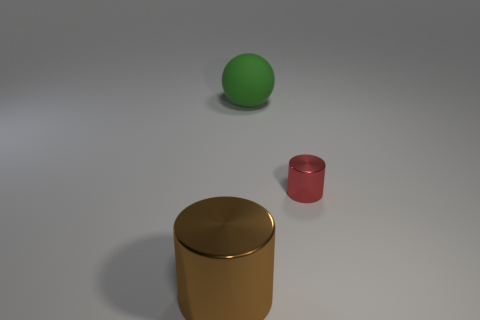Are there any brown things that have the same size as the green sphere?
Offer a terse response. Yes. There is a tiny cylinder that is the same material as the brown thing; what is its color?
Keep it short and to the point. Red. There is a large thing that is behind the large shiny cylinder; what number of balls are in front of it?
Your answer should be compact. 0. What is the thing that is both in front of the big matte thing and to the left of the small object made of?
Make the answer very short. Metal. Do the metal object that is to the left of the small red metal object and the large green thing have the same shape?
Offer a very short reply. No. Is the number of large blue matte cylinders less than the number of large green rubber things?
Your response must be concise. Yes. Does the large sphere have the same color as the metal cylinder to the right of the big rubber object?
Your answer should be very brief. No. Is the number of cylinders greater than the number of big cyan things?
Your response must be concise. Yes. What is the size of the brown thing that is the same shape as the red thing?
Your response must be concise. Large. Are the green thing and the big brown cylinder on the left side of the small cylinder made of the same material?
Make the answer very short. No. 